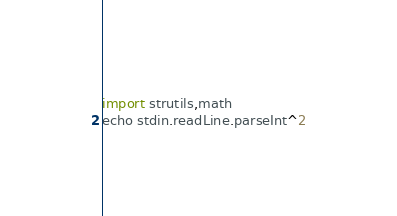Convert code to text. <code><loc_0><loc_0><loc_500><loc_500><_Nim_>import strutils,math
echo stdin.readLine.parseInt^2</code> 